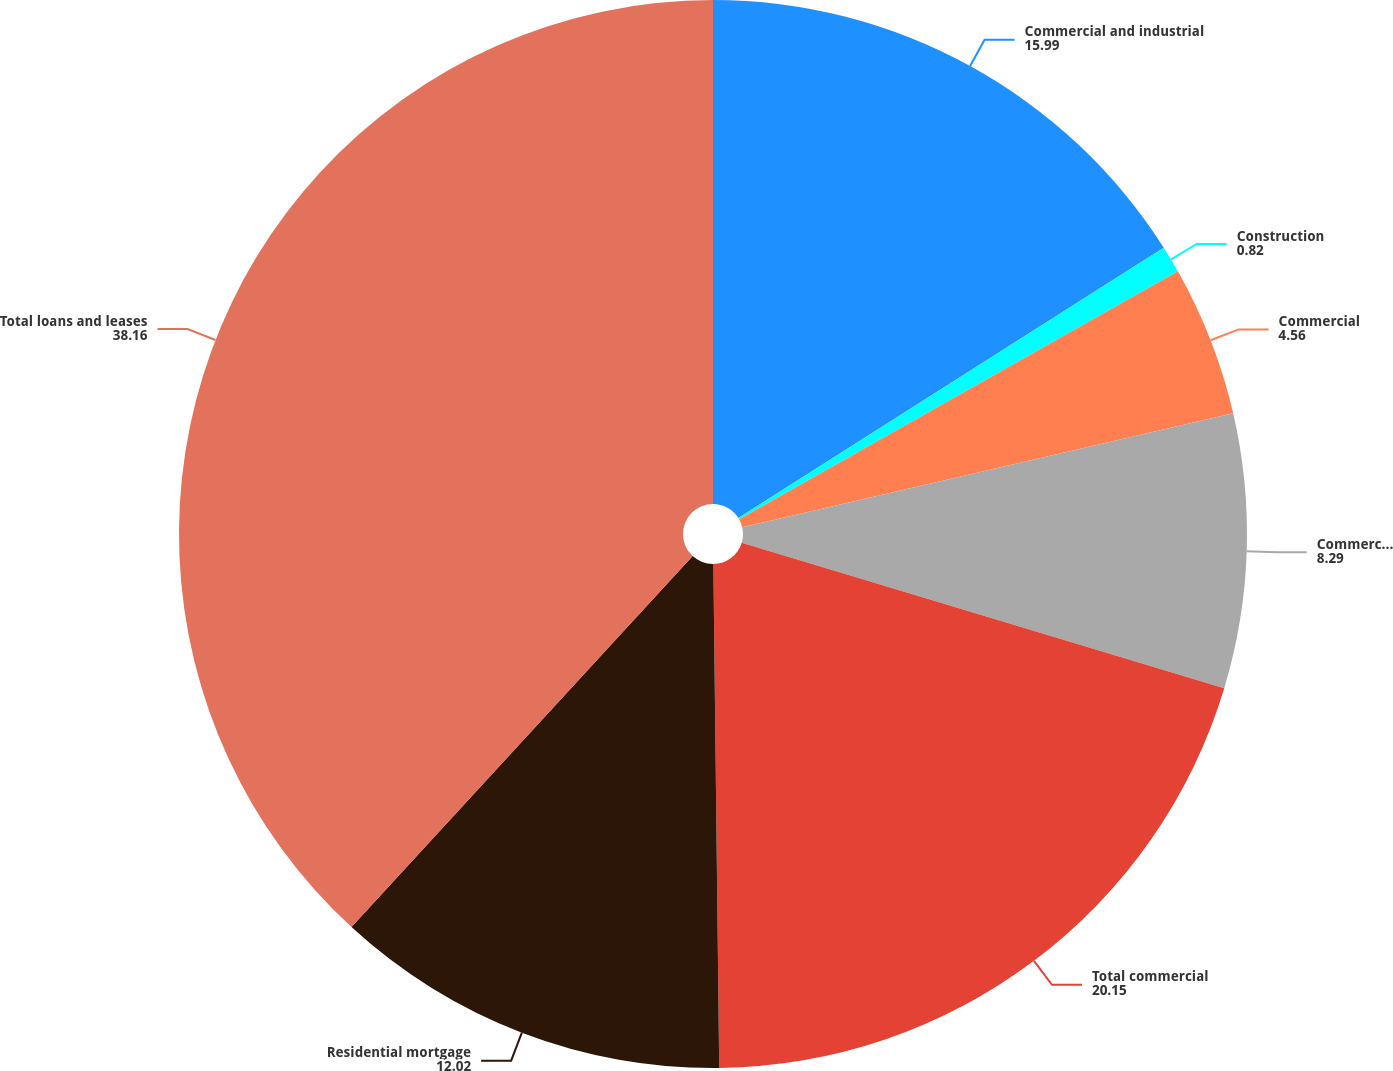Convert chart to OTSL. <chart><loc_0><loc_0><loc_500><loc_500><pie_chart><fcel>Commercial and industrial<fcel>Construction<fcel>Commercial<fcel>Commercial real estate<fcel>Total commercial<fcel>Residential mortgage<fcel>Total loans and leases<nl><fcel>15.99%<fcel>0.82%<fcel>4.56%<fcel>8.29%<fcel>20.15%<fcel>12.02%<fcel>38.16%<nl></chart> 